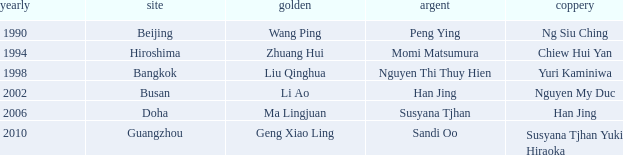I'm looking to parse the entire table for insights. Could you assist me with that? {'header': ['yearly', 'site', 'golden', 'argent', 'coppery'], 'rows': [['1990', 'Beijing', 'Wang Ping', 'Peng Ying', 'Ng Siu Ching'], ['1994', 'Hiroshima', 'Zhuang Hui', 'Momi Matsumura', 'Chiew Hui Yan'], ['1998', 'Bangkok', 'Liu Qinghua', 'Nguyen Thi Thuy Hien', 'Yuri Kaminiwa'], ['2002', 'Busan', 'Li Ao', 'Han Jing', 'Nguyen My Duc'], ['2006', 'Doha', 'Ma Lingjuan', 'Susyana Tjhan', 'Han Jing'], ['2010', 'Guangzhou', 'Geng Xiao Ling', 'Sandi Oo', 'Susyana Tjhan Yuki Hiraoka']]} Which gold corresponds to the year 1994? Zhuang Hui. 